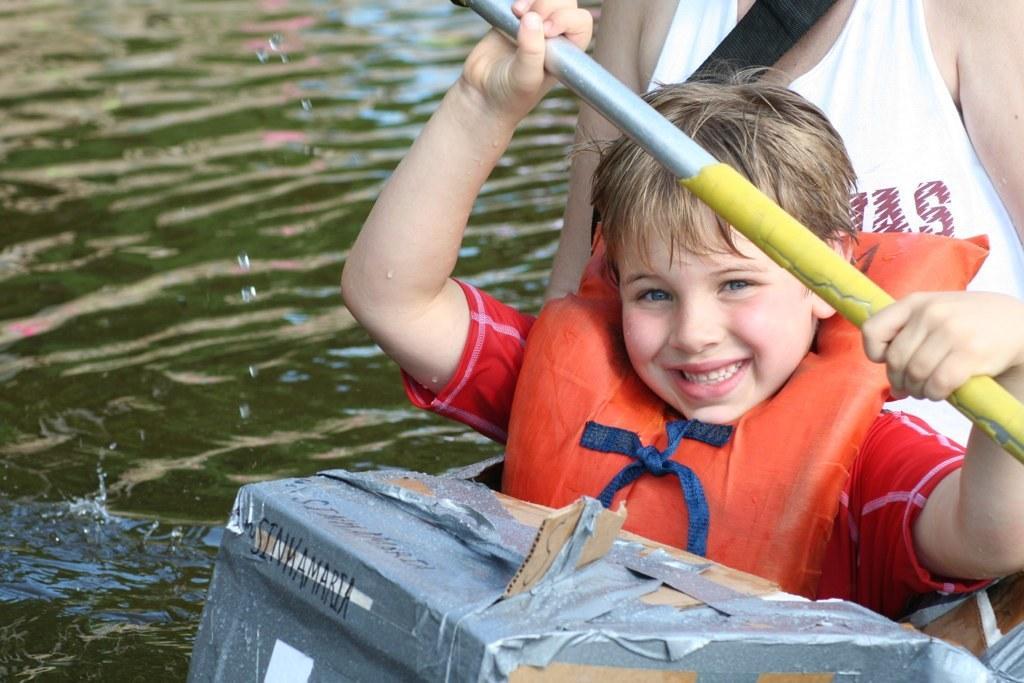Please provide a concise description of this image. On the right side of the image we can see a person is wearing a belt and a boy is wearing a jacket and holding a rod, in-front of him a box is there. In the background of the image we can see the water. 